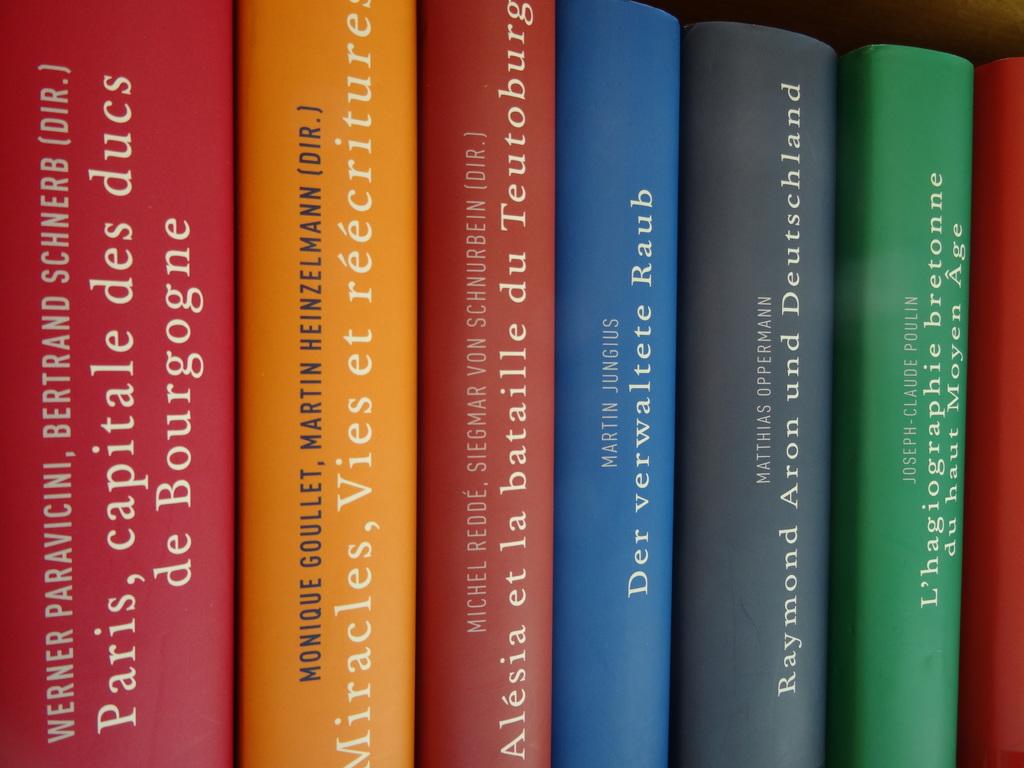Who are the authors of the orange book?
Give a very brief answer. Monique goullet, martin heinzelmann. What's the title of the light blue book?
Your answer should be very brief. Der verwaltete raub. 